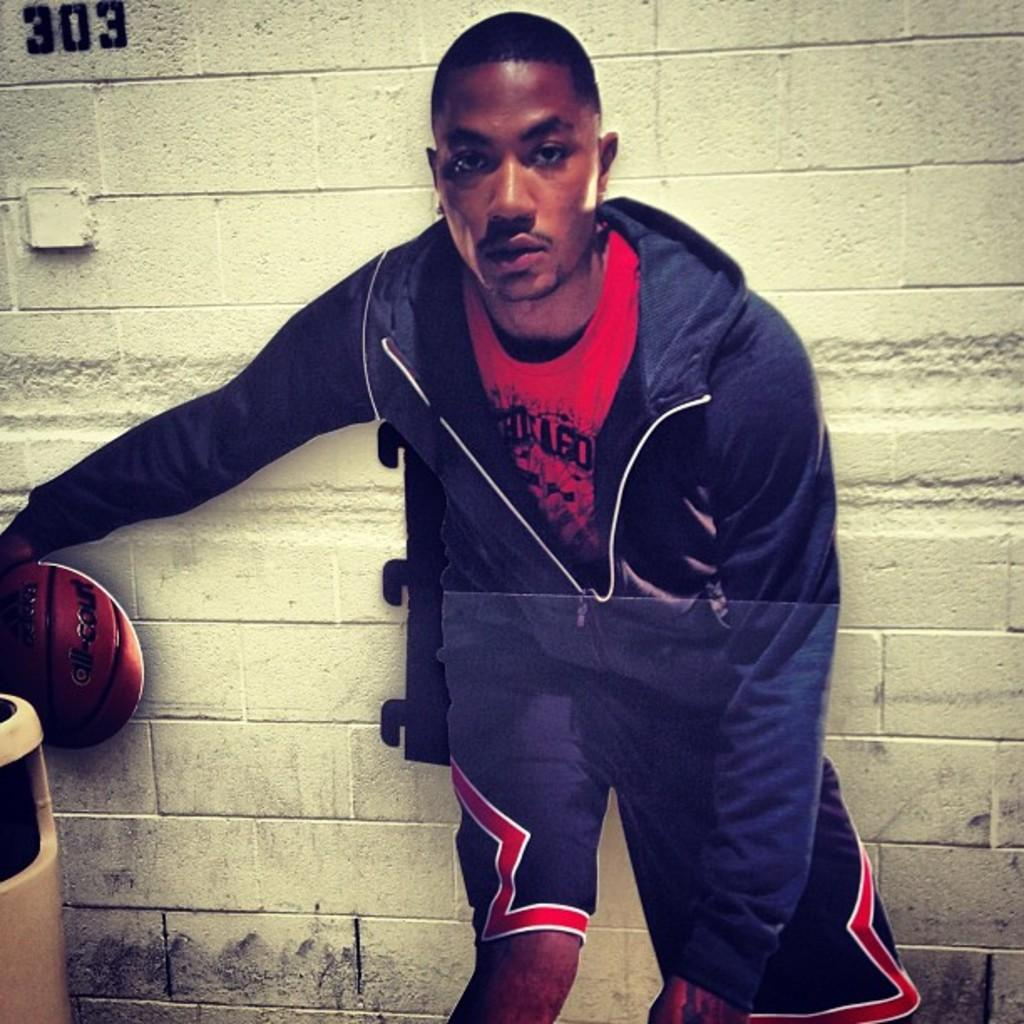<image>
Render a clear and concise summary of the photo. A black man dribbles a basketball in front of a while wall with the number 303 on it. 